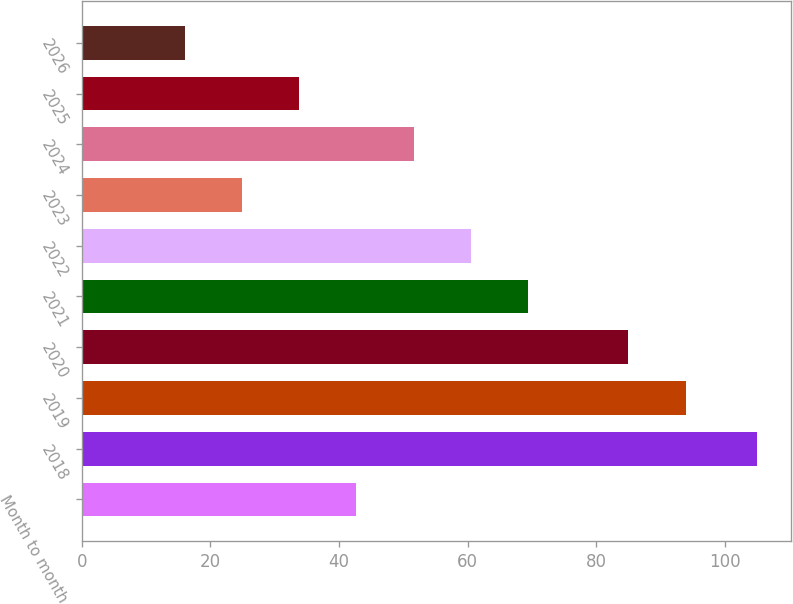Convert chart. <chart><loc_0><loc_0><loc_500><loc_500><bar_chart><fcel>Month to month<fcel>2018<fcel>2019<fcel>2020<fcel>2021<fcel>2022<fcel>2023<fcel>2024<fcel>2025<fcel>2026<nl><fcel>42.7<fcel>105<fcel>94<fcel>85<fcel>69.4<fcel>60.5<fcel>24.9<fcel>51.6<fcel>33.8<fcel>16<nl></chart> 